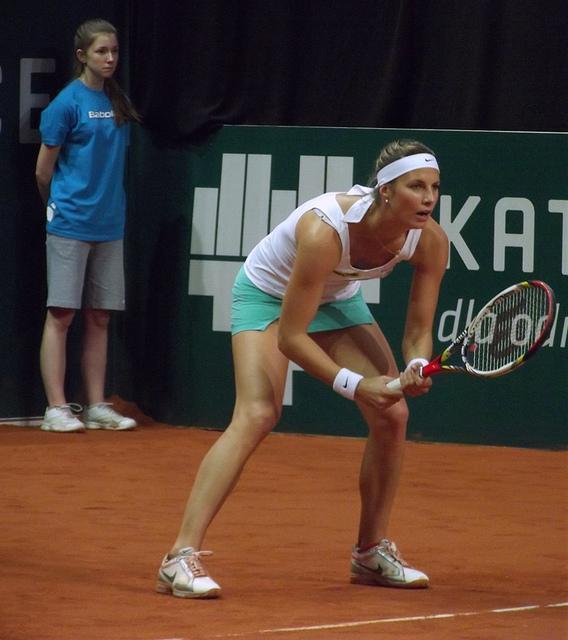How many people can you see?
Give a very brief answer. 2. 